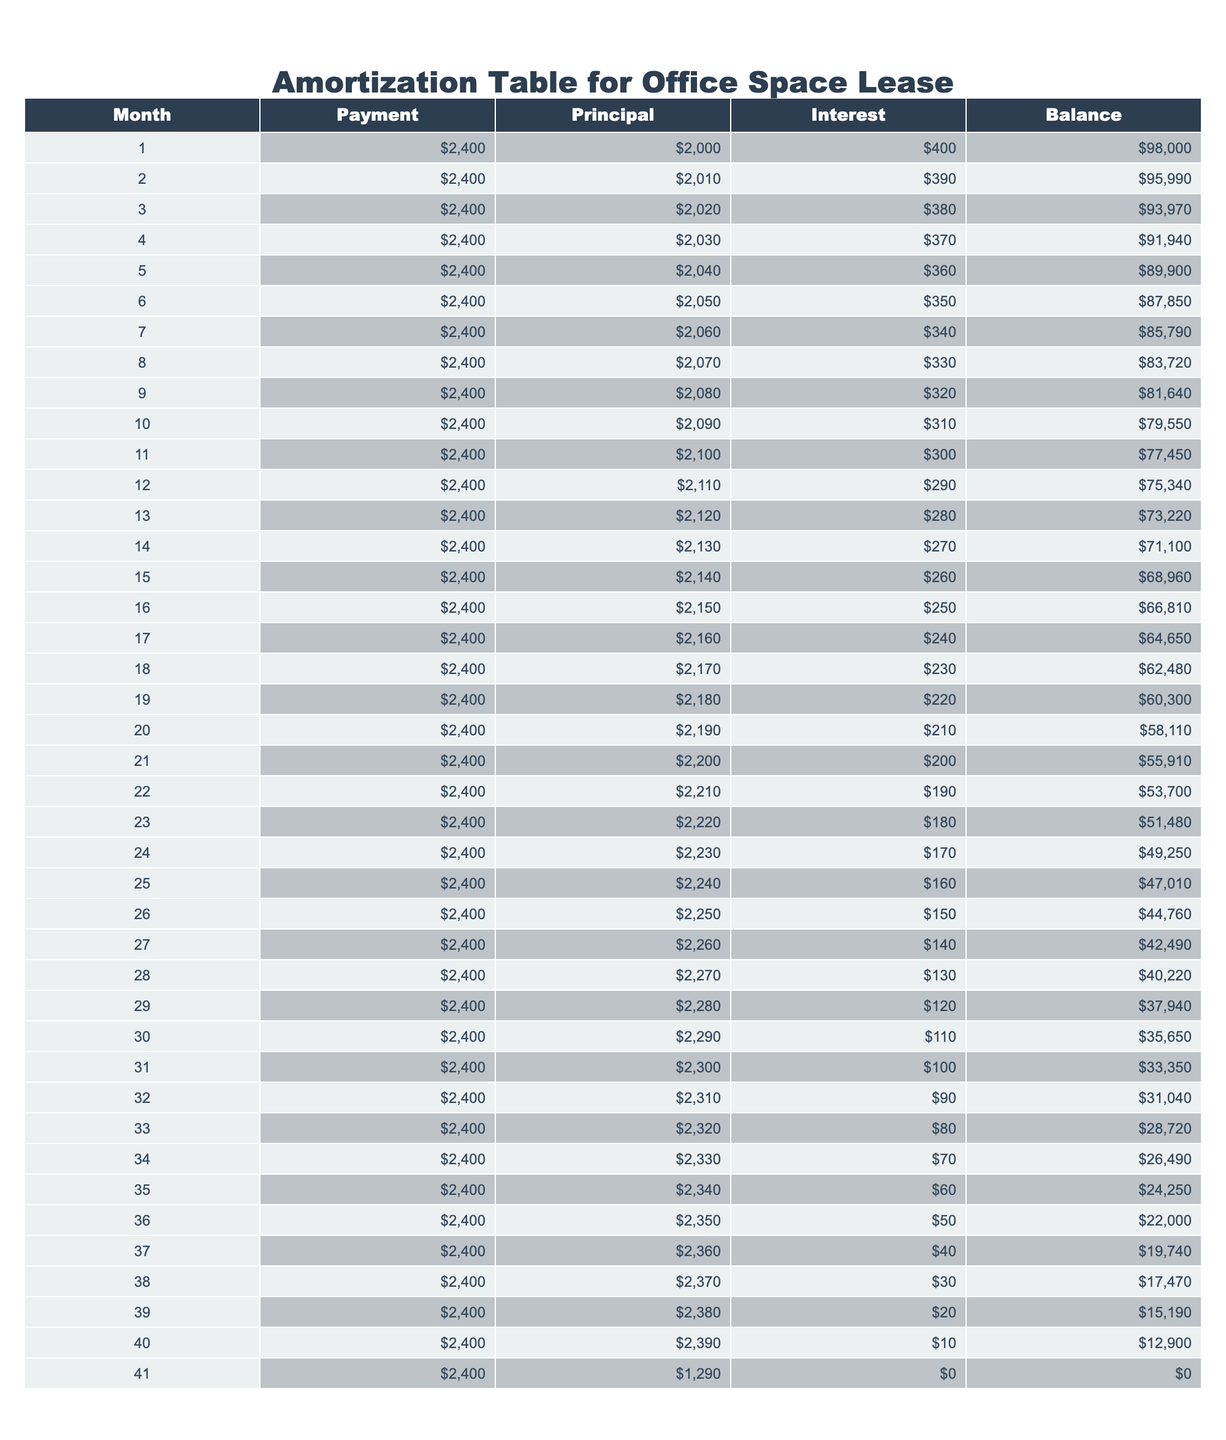What is the total amount paid in the first month? The first month's payment is listed as $2400. The amount paid is directly shown in the table under the "Payment" column for Month 1.
Answer: $2400 In which month did the principal payment exceed $2300? By examining the "Principal" column, it shows that the principal payment for Month 33 is $2320, which exceeds $2300. Prior to that, it is less than $2300.
Answer: Month 33 What is the total interest paid over the first six months? By adding the interest amounts from the first six months: 400 + 390 + 380 + 370 + 360 + 350 = 2250. The sum gives the total interest over that period.
Answer: $2250 Is there a month when the interest payment was $0? The table shows that the last month's interest payment (Month 41) is $0.
Answer: Yes What is the average monthly payment for the duration of the loan? The total payment over 41 months (41 * $2400) is calculated to be $98,400. Dividing this by the number of months (41) results in an average payment of $2400.
Answer: $2400 In which month was the remaining balance below $50,000? The balance falls below $50,000 in Month 21 when it shows $55910. The balance remaining continues to reduce each month until it reaches 0 by Month 41.
Answer: Month 21 What is the difference between the principal paid in Month 41 and Month 1? The principal paid in Month 41 is $1290, and in Month 1, it is $2000. The difference is calculated as $2000 - $1290 = $710.
Answer: $710 How much total principal was paid in the last six months? The total principal from Month 36 to Month 41 is: 2350 + 2360 + 2370 + 2380 + 2390 + 1290 =  12130. This sum gives the total principal paid in the last six months of the table.
Answer: $12130 How does the interest payment in Month 24 compare to the interest in Month 12? By looking at the "Interest" column, Month 24 has an interest payment of $170, and Month 12 has an interest payment of $290. The interest in Month 24 is less than in Month 12 by subtracting the two: $290 - $170 = $120.
Answer: Month 24 is less by $120 